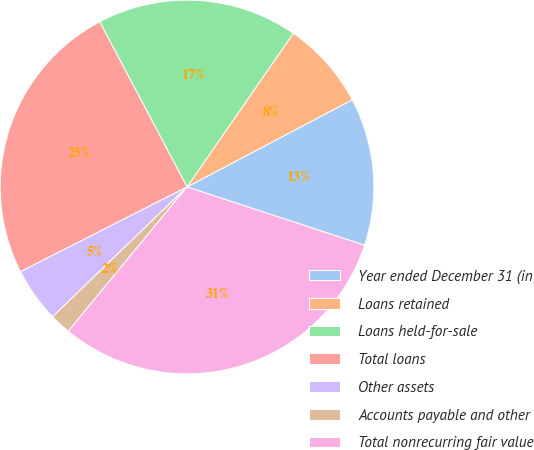Convert chart. <chart><loc_0><loc_0><loc_500><loc_500><pie_chart><fcel>Year ended December 31 (in<fcel>Loans retained<fcel>Loans held-for-sale<fcel>Total loans<fcel>Other assets<fcel>Accounts payable and other<fcel>Total nonrecurring fair value<nl><fcel>12.78%<fcel>7.64%<fcel>17.37%<fcel>24.75%<fcel>4.73%<fcel>1.81%<fcel>30.92%<nl></chart> 